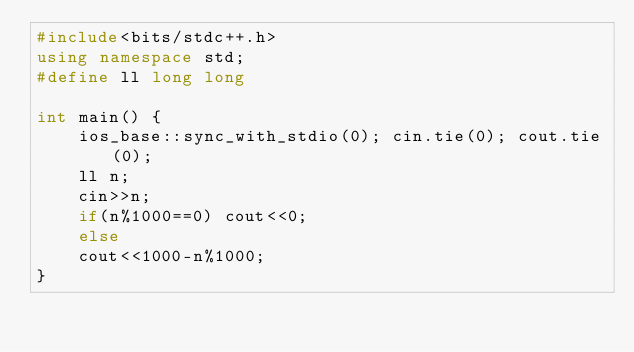Convert code to text. <code><loc_0><loc_0><loc_500><loc_500><_C++_>#include<bits/stdc++.h>
using namespace std;
#define ll long long
 
int main() {
	ios_base::sync_with_stdio(0); cin.tie(0); cout.tie(0);
	ll n;
	cin>>n;
	if(n%1000==0) cout<<0;
	else
	cout<<1000-n%1000;
}</code> 